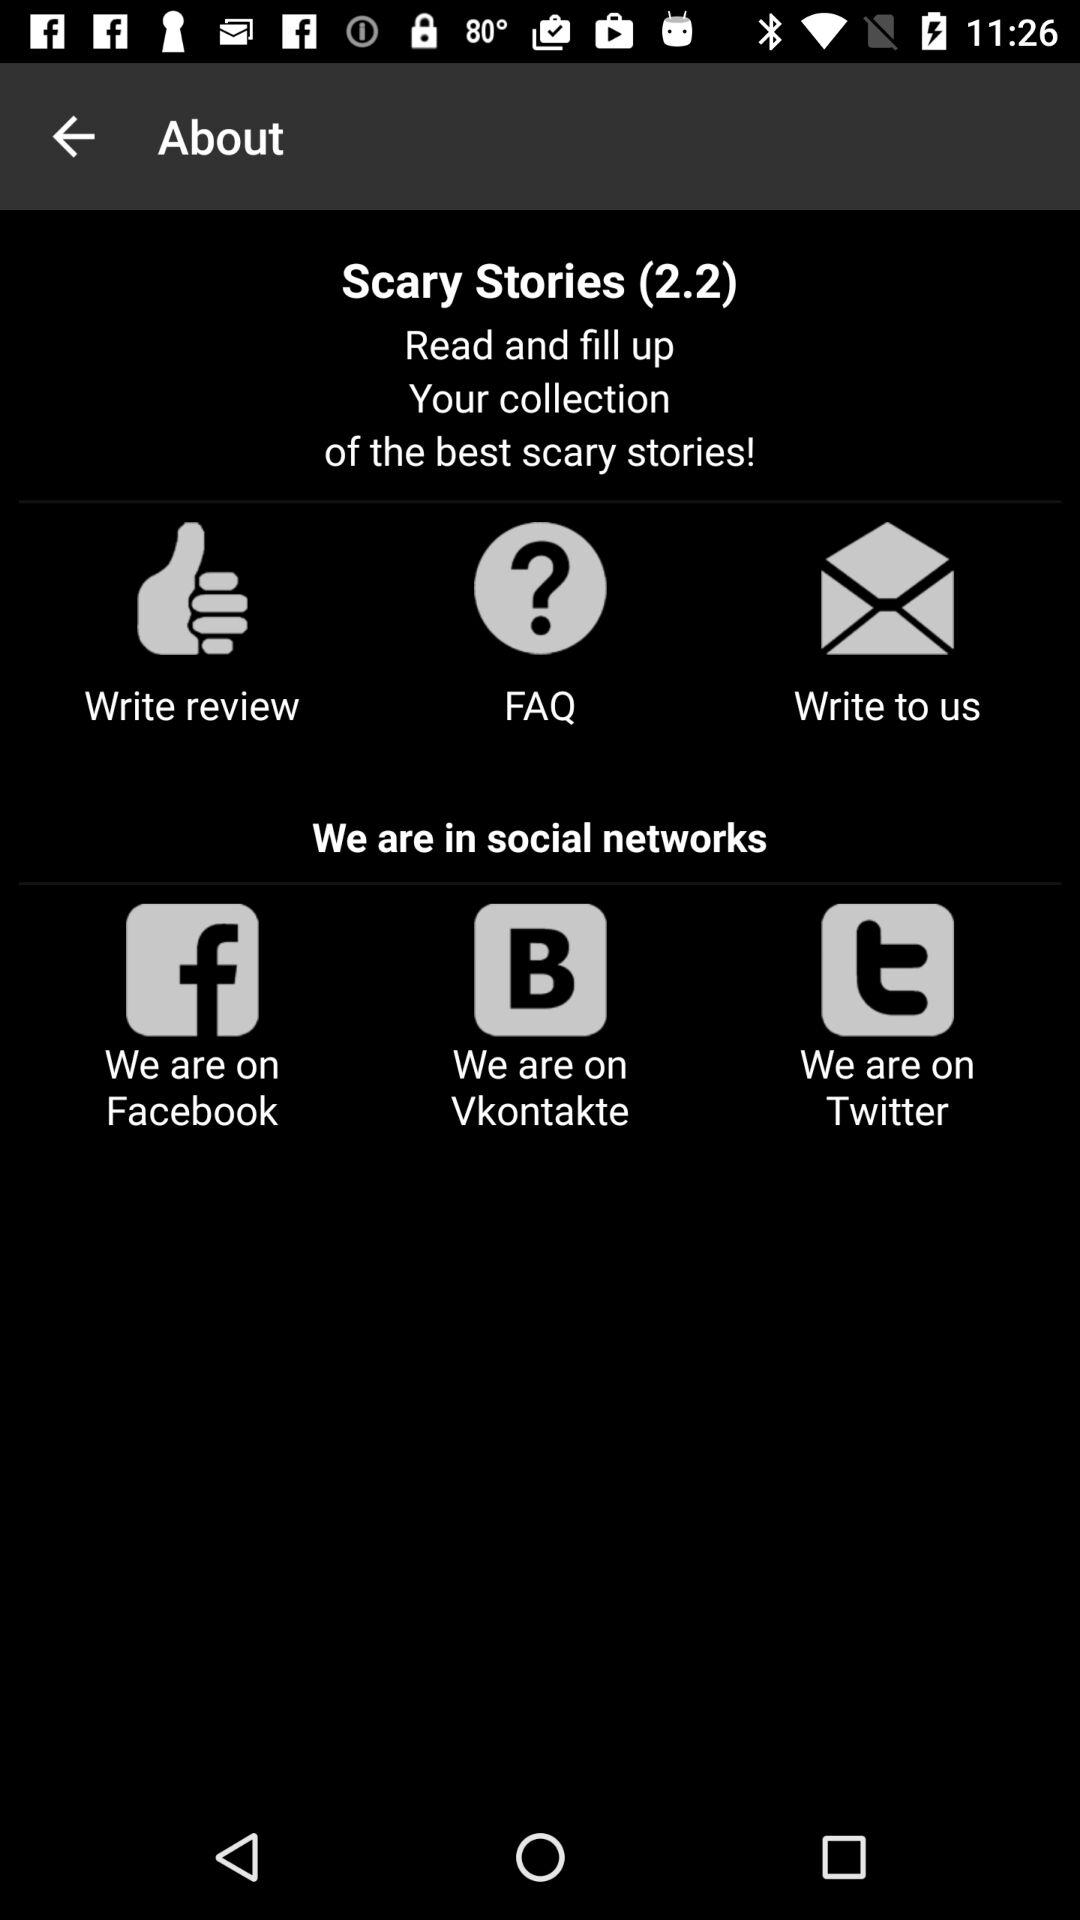What social networks are Scary Stories on? The social networks are "Facebook", "Vkontakte" and "Twitter". 